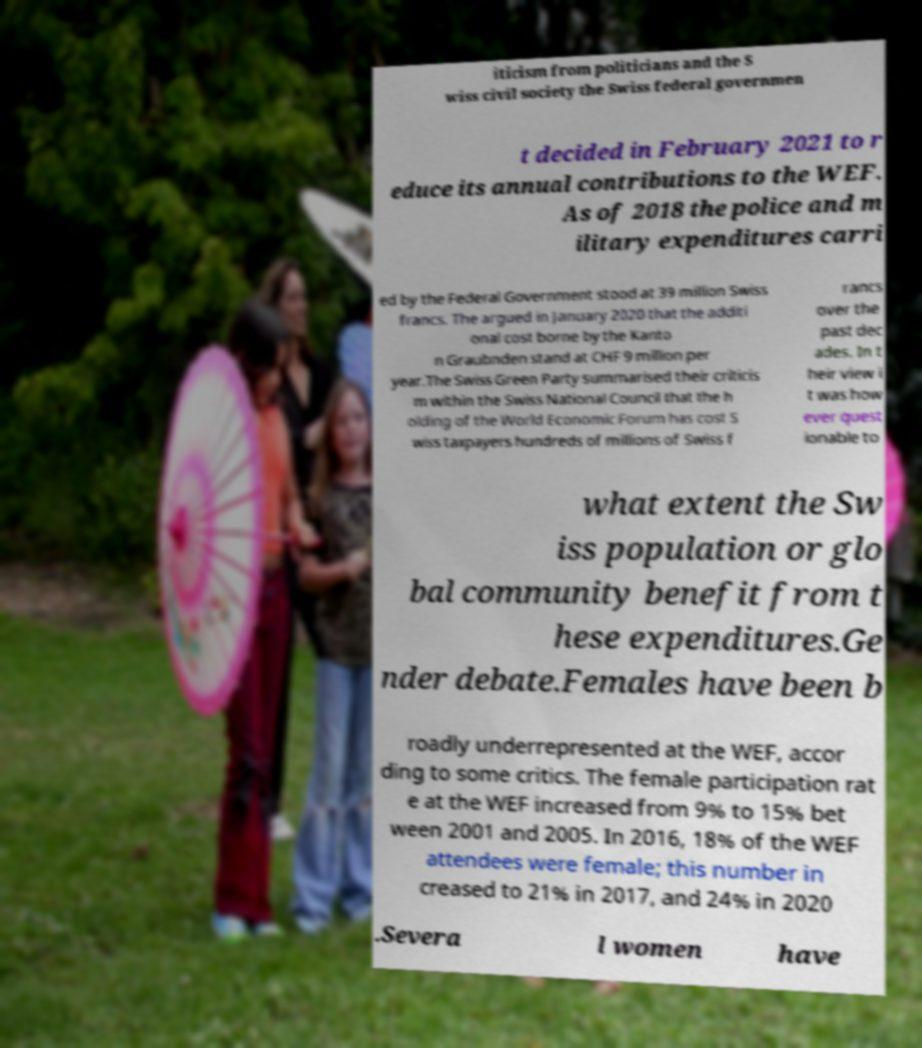There's text embedded in this image that I need extracted. Can you transcribe it verbatim? iticism from politicians and the S wiss civil society the Swiss federal governmen t decided in February 2021 to r educe its annual contributions to the WEF. As of 2018 the police and m ilitary expenditures carri ed by the Federal Government stood at 39 million Swiss francs. The argued in January 2020 that the additi onal cost borne by the Kanto n Graubnden stand at CHF 9 million per year.The Swiss Green Party summarised their criticis m within the Swiss National Council that the h olding of the World Economic Forum has cost S wiss taxpayers hundreds of millions of Swiss f rancs over the past dec ades. In t heir view i t was how ever quest ionable to what extent the Sw iss population or glo bal community benefit from t hese expenditures.Ge nder debate.Females have been b roadly underrepresented at the WEF, accor ding to some critics. The female participation rat e at the WEF increased from 9% to 15% bet ween 2001 and 2005. In 2016, 18% of the WEF attendees were female; this number in creased to 21% in 2017, and 24% in 2020 .Severa l women have 